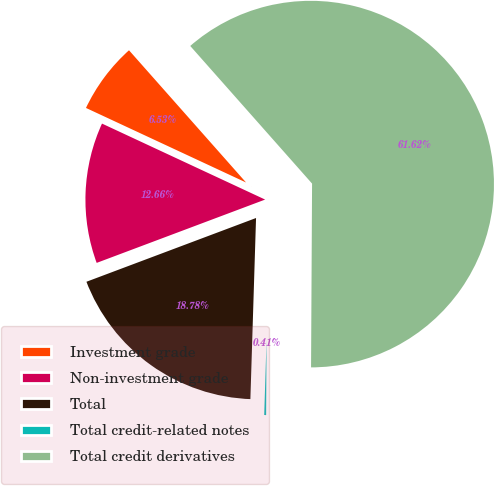Convert chart. <chart><loc_0><loc_0><loc_500><loc_500><pie_chart><fcel>Investment grade<fcel>Non-investment grade<fcel>Total<fcel>Total credit-related notes<fcel>Total credit derivatives<nl><fcel>6.53%<fcel>12.66%<fcel>18.78%<fcel>0.41%<fcel>61.62%<nl></chart> 